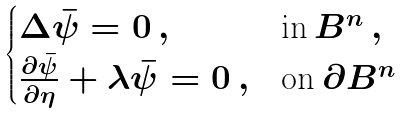<formula> <loc_0><loc_0><loc_500><loc_500>\begin{cases} \Delta \bar { \psi } = 0 \, , & \text {in} \, B ^ { n } \, , \\ \frac { \partial \bar { \psi } } { \partial \eta } + \lambda \bar { \psi } = 0 \, , & \text {on} \, \partial B ^ { n } \end{cases}</formula> 